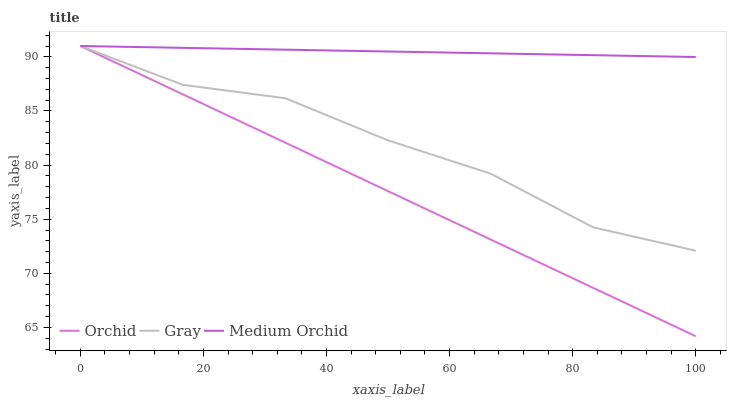Does Orchid have the minimum area under the curve?
Answer yes or no. Yes. Does Medium Orchid have the maximum area under the curve?
Answer yes or no. Yes. Does Medium Orchid have the minimum area under the curve?
Answer yes or no. No. Does Orchid have the maximum area under the curve?
Answer yes or no. No. Is Orchid the smoothest?
Answer yes or no. Yes. Is Gray the roughest?
Answer yes or no. Yes. Is Medium Orchid the smoothest?
Answer yes or no. No. Is Medium Orchid the roughest?
Answer yes or no. No. Does Orchid have the lowest value?
Answer yes or no. Yes. Does Medium Orchid have the lowest value?
Answer yes or no. No. Does Orchid have the highest value?
Answer yes or no. Yes. Does Gray intersect Orchid?
Answer yes or no. Yes. Is Gray less than Orchid?
Answer yes or no. No. Is Gray greater than Orchid?
Answer yes or no. No. 